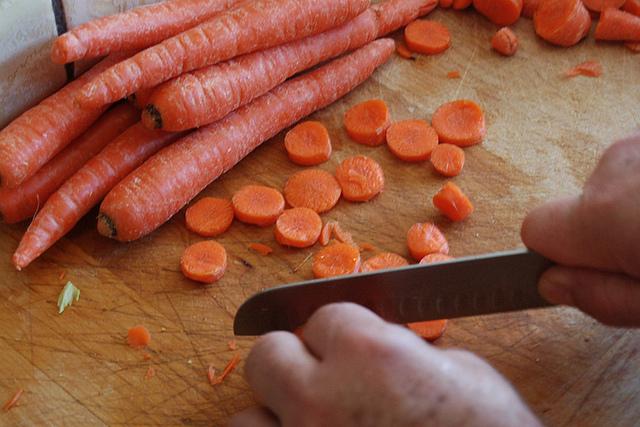Is the person right handed?
Be succinct. Yes. What is the orange vegetable?
Write a very short answer. Carrot. What is that person cutting on?
Quick response, please. Cutting board. 